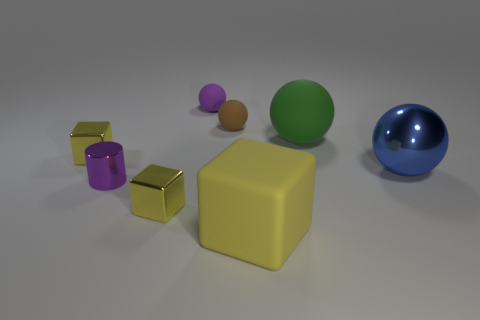Is there any other thing that is the same shape as the purple metal object?
Offer a very short reply. No. Is there a small green shiny object?
Your answer should be very brief. No. Is the number of big yellow matte objects less than the number of tiny metal things?
Your answer should be very brief. Yes. What number of blocks have the same material as the brown sphere?
Your response must be concise. 1. There is a large ball that is the same material as the small purple ball; what is its color?
Provide a short and direct response. Green. The big green object is what shape?
Your answer should be compact. Sphere. How many matte balls have the same color as the small metal cylinder?
Offer a very short reply. 1. The yellow object that is the same size as the green matte ball is what shape?
Your answer should be very brief. Cube. Is there a brown object that has the same size as the purple cylinder?
Your response must be concise. Yes. What is the material of the cylinder that is the same size as the brown sphere?
Your response must be concise. Metal. 